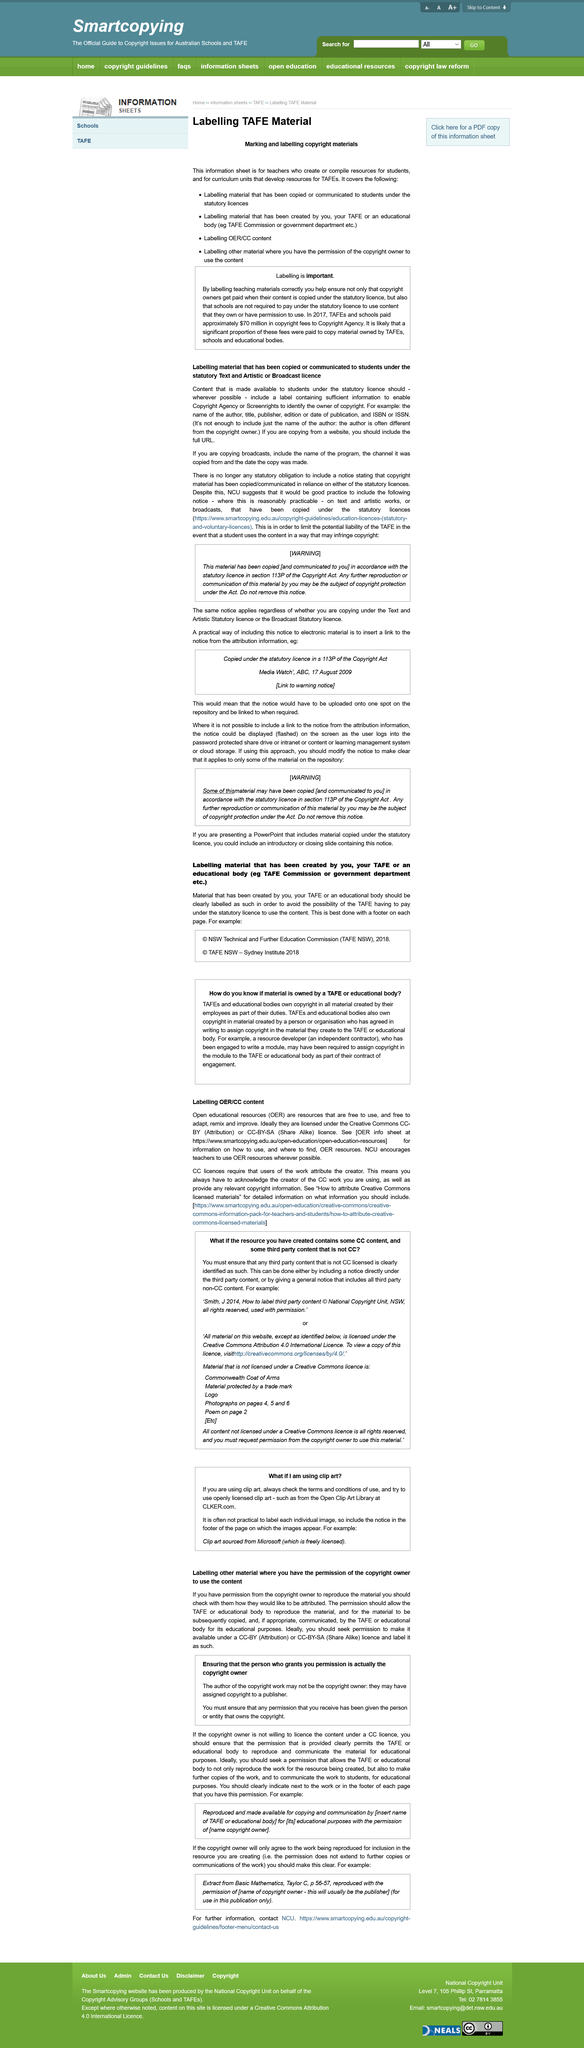Identify some key points in this picture. Content made available to students under the Text and Artistic license should include a label, as it is necessary to clearly indicate the license terms to users. If you are copying information from a website, it is necessary to include the full URL in the citation. It is not sufficient to include only the name of the author in the content made available to students when using the specified license. 